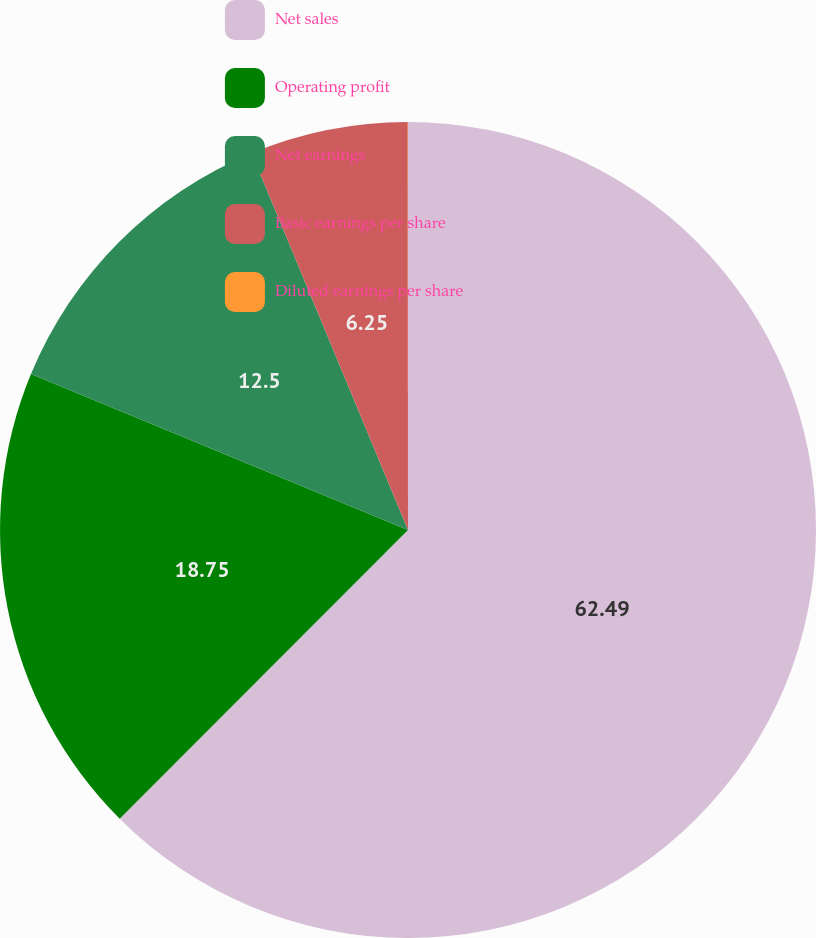<chart> <loc_0><loc_0><loc_500><loc_500><pie_chart><fcel>Net sales<fcel>Operating profit<fcel>Net earnings<fcel>Basic earnings per share<fcel>Diluted earnings per share<nl><fcel>62.49%<fcel>18.75%<fcel>12.5%<fcel>6.25%<fcel>0.01%<nl></chart> 